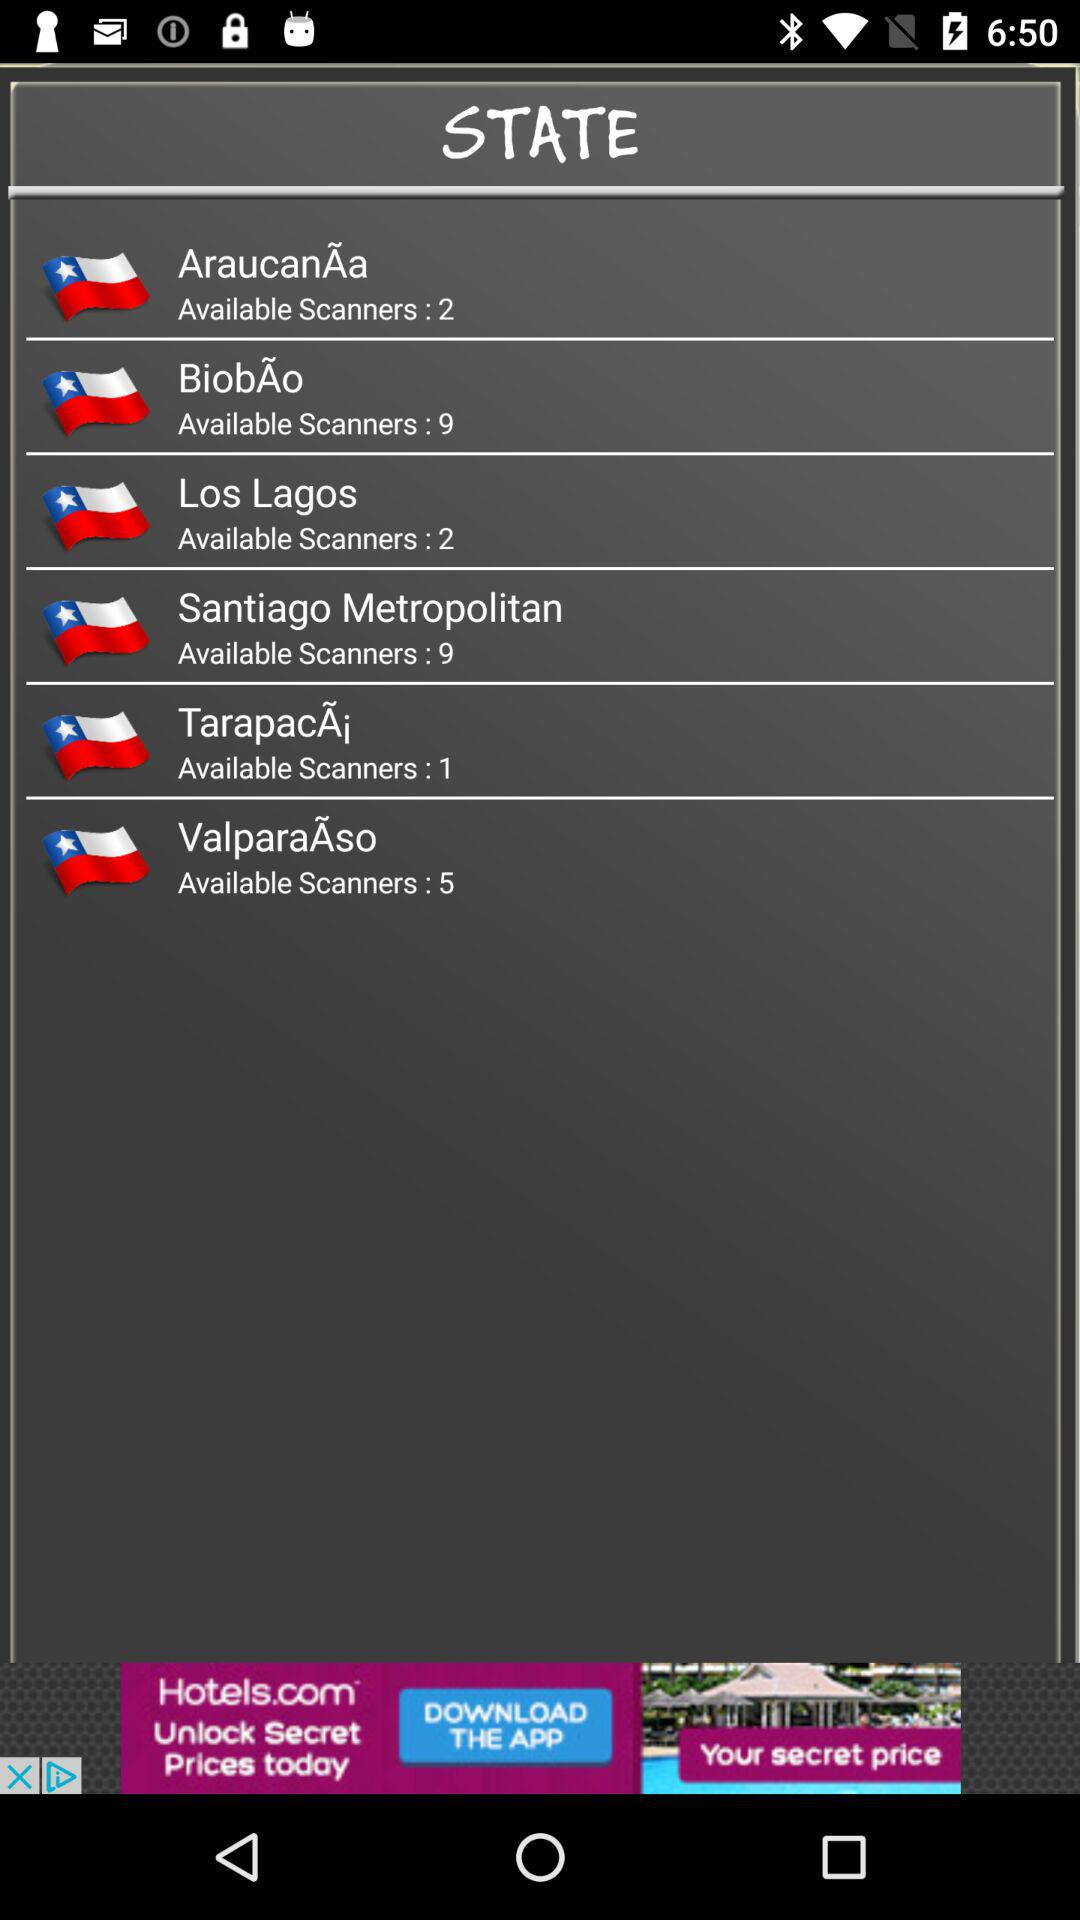How many regions have less than 5 available scanners?
Answer the question using a single word or phrase. 3 